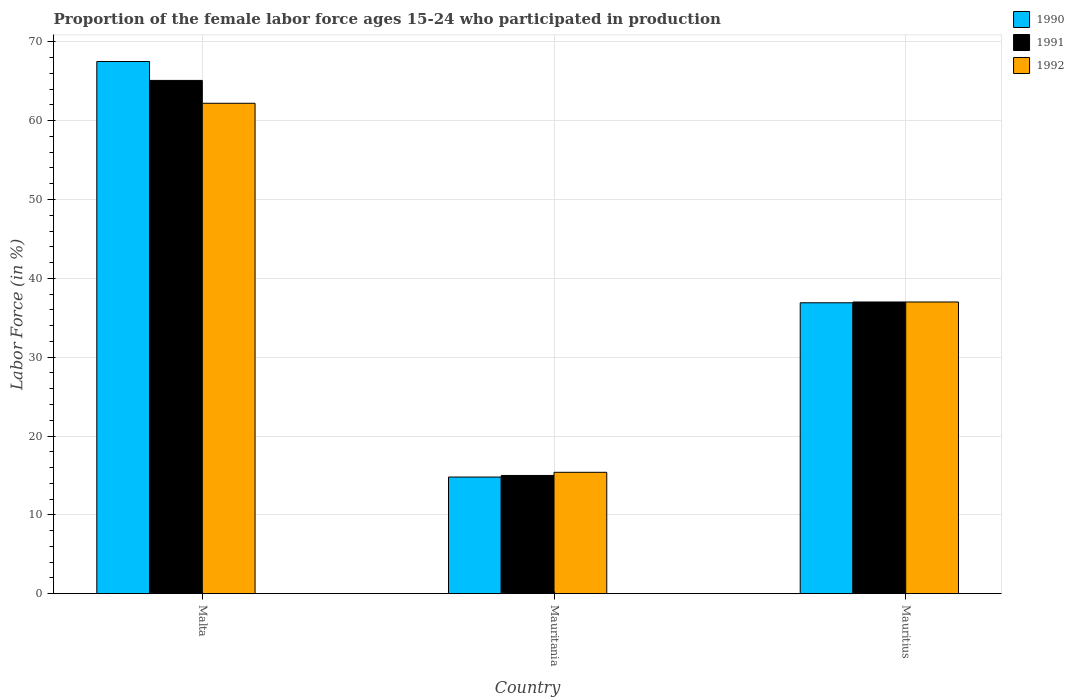How many groups of bars are there?
Offer a very short reply. 3. Are the number of bars on each tick of the X-axis equal?
Provide a short and direct response. Yes. How many bars are there on the 2nd tick from the left?
Ensure brevity in your answer.  3. How many bars are there on the 1st tick from the right?
Your answer should be very brief. 3. What is the label of the 1st group of bars from the left?
Give a very brief answer. Malta. In how many cases, is the number of bars for a given country not equal to the number of legend labels?
Offer a very short reply. 0. What is the proportion of the female labor force who participated in production in 1990 in Mauritania?
Provide a succinct answer. 14.8. Across all countries, what is the maximum proportion of the female labor force who participated in production in 1992?
Offer a very short reply. 62.2. Across all countries, what is the minimum proportion of the female labor force who participated in production in 1990?
Provide a short and direct response. 14.8. In which country was the proportion of the female labor force who participated in production in 1990 maximum?
Keep it short and to the point. Malta. In which country was the proportion of the female labor force who participated in production in 1992 minimum?
Offer a terse response. Mauritania. What is the total proportion of the female labor force who participated in production in 1992 in the graph?
Make the answer very short. 114.6. What is the difference between the proportion of the female labor force who participated in production in 1991 in Malta and the proportion of the female labor force who participated in production in 1990 in Mauritania?
Offer a terse response. 50.3. What is the average proportion of the female labor force who participated in production in 1990 per country?
Your answer should be compact. 39.73. What is the difference between the proportion of the female labor force who participated in production of/in 1990 and proportion of the female labor force who participated in production of/in 1991 in Malta?
Keep it short and to the point. 2.4. In how many countries, is the proportion of the female labor force who participated in production in 1992 greater than 32 %?
Offer a very short reply. 2. What is the ratio of the proportion of the female labor force who participated in production in 1992 in Malta to that in Mauritius?
Keep it short and to the point. 1.68. What is the difference between the highest and the second highest proportion of the female labor force who participated in production in 1992?
Your response must be concise. -25.2. What is the difference between the highest and the lowest proportion of the female labor force who participated in production in 1992?
Give a very brief answer. 46.8. Is the sum of the proportion of the female labor force who participated in production in 1990 in Malta and Mauritania greater than the maximum proportion of the female labor force who participated in production in 1992 across all countries?
Make the answer very short. Yes. What does the 1st bar from the left in Mauritania represents?
Your answer should be very brief. 1990. What does the 1st bar from the right in Mauritius represents?
Your answer should be very brief. 1992. Are all the bars in the graph horizontal?
Provide a succinct answer. No. How many countries are there in the graph?
Make the answer very short. 3. Are the values on the major ticks of Y-axis written in scientific E-notation?
Your answer should be compact. No. Does the graph contain any zero values?
Your answer should be very brief. No. Does the graph contain grids?
Provide a short and direct response. Yes. Where does the legend appear in the graph?
Provide a succinct answer. Top right. How many legend labels are there?
Keep it short and to the point. 3. What is the title of the graph?
Make the answer very short. Proportion of the female labor force ages 15-24 who participated in production. Does "2004" appear as one of the legend labels in the graph?
Offer a very short reply. No. What is the label or title of the Y-axis?
Your answer should be very brief. Labor Force (in %). What is the Labor Force (in %) in 1990 in Malta?
Offer a very short reply. 67.5. What is the Labor Force (in %) of 1991 in Malta?
Provide a succinct answer. 65.1. What is the Labor Force (in %) of 1992 in Malta?
Offer a terse response. 62.2. What is the Labor Force (in %) of 1990 in Mauritania?
Your answer should be compact. 14.8. What is the Labor Force (in %) in 1991 in Mauritania?
Provide a succinct answer. 15. What is the Labor Force (in %) of 1992 in Mauritania?
Your response must be concise. 15.4. What is the Labor Force (in %) in 1990 in Mauritius?
Your answer should be very brief. 36.9. Across all countries, what is the maximum Labor Force (in %) of 1990?
Your response must be concise. 67.5. Across all countries, what is the maximum Labor Force (in %) in 1991?
Your answer should be compact. 65.1. Across all countries, what is the maximum Labor Force (in %) of 1992?
Make the answer very short. 62.2. Across all countries, what is the minimum Labor Force (in %) in 1990?
Your answer should be very brief. 14.8. Across all countries, what is the minimum Labor Force (in %) of 1992?
Keep it short and to the point. 15.4. What is the total Labor Force (in %) in 1990 in the graph?
Your response must be concise. 119.2. What is the total Labor Force (in %) of 1991 in the graph?
Provide a succinct answer. 117.1. What is the total Labor Force (in %) in 1992 in the graph?
Provide a succinct answer. 114.6. What is the difference between the Labor Force (in %) in 1990 in Malta and that in Mauritania?
Make the answer very short. 52.7. What is the difference between the Labor Force (in %) in 1991 in Malta and that in Mauritania?
Offer a very short reply. 50.1. What is the difference between the Labor Force (in %) in 1992 in Malta and that in Mauritania?
Your response must be concise. 46.8. What is the difference between the Labor Force (in %) of 1990 in Malta and that in Mauritius?
Ensure brevity in your answer.  30.6. What is the difference between the Labor Force (in %) in 1991 in Malta and that in Mauritius?
Keep it short and to the point. 28.1. What is the difference between the Labor Force (in %) of 1992 in Malta and that in Mauritius?
Give a very brief answer. 25.2. What is the difference between the Labor Force (in %) of 1990 in Mauritania and that in Mauritius?
Your response must be concise. -22.1. What is the difference between the Labor Force (in %) of 1991 in Mauritania and that in Mauritius?
Ensure brevity in your answer.  -22. What is the difference between the Labor Force (in %) in 1992 in Mauritania and that in Mauritius?
Offer a very short reply. -21.6. What is the difference between the Labor Force (in %) in 1990 in Malta and the Labor Force (in %) in 1991 in Mauritania?
Give a very brief answer. 52.5. What is the difference between the Labor Force (in %) of 1990 in Malta and the Labor Force (in %) of 1992 in Mauritania?
Make the answer very short. 52.1. What is the difference between the Labor Force (in %) in 1991 in Malta and the Labor Force (in %) in 1992 in Mauritania?
Offer a terse response. 49.7. What is the difference between the Labor Force (in %) in 1990 in Malta and the Labor Force (in %) in 1991 in Mauritius?
Give a very brief answer. 30.5. What is the difference between the Labor Force (in %) in 1990 in Malta and the Labor Force (in %) in 1992 in Mauritius?
Your answer should be compact. 30.5. What is the difference between the Labor Force (in %) in 1991 in Malta and the Labor Force (in %) in 1992 in Mauritius?
Make the answer very short. 28.1. What is the difference between the Labor Force (in %) of 1990 in Mauritania and the Labor Force (in %) of 1991 in Mauritius?
Ensure brevity in your answer.  -22.2. What is the difference between the Labor Force (in %) in 1990 in Mauritania and the Labor Force (in %) in 1992 in Mauritius?
Your answer should be compact. -22.2. What is the average Labor Force (in %) of 1990 per country?
Keep it short and to the point. 39.73. What is the average Labor Force (in %) in 1991 per country?
Keep it short and to the point. 39.03. What is the average Labor Force (in %) in 1992 per country?
Provide a succinct answer. 38.2. What is the difference between the Labor Force (in %) of 1990 and Labor Force (in %) of 1991 in Malta?
Ensure brevity in your answer.  2.4. What is the difference between the Labor Force (in %) of 1991 and Labor Force (in %) of 1992 in Malta?
Keep it short and to the point. 2.9. What is the difference between the Labor Force (in %) in 1990 and Labor Force (in %) in 1992 in Mauritania?
Make the answer very short. -0.6. What is the difference between the Labor Force (in %) of 1991 and Labor Force (in %) of 1992 in Mauritania?
Your answer should be very brief. -0.4. What is the difference between the Labor Force (in %) of 1990 and Labor Force (in %) of 1992 in Mauritius?
Offer a terse response. -0.1. What is the difference between the Labor Force (in %) in 1991 and Labor Force (in %) in 1992 in Mauritius?
Make the answer very short. 0. What is the ratio of the Labor Force (in %) of 1990 in Malta to that in Mauritania?
Make the answer very short. 4.56. What is the ratio of the Labor Force (in %) in 1991 in Malta to that in Mauritania?
Your answer should be compact. 4.34. What is the ratio of the Labor Force (in %) in 1992 in Malta to that in Mauritania?
Ensure brevity in your answer.  4.04. What is the ratio of the Labor Force (in %) of 1990 in Malta to that in Mauritius?
Give a very brief answer. 1.83. What is the ratio of the Labor Force (in %) of 1991 in Malta to that in Mauritius?
Your answer should be compact. 1.76. What is the ratio of the Labor Force (in %) in 1992 in Malta to that in Mauritius?
Your response must be concise. 1.68. What is the ratio of the Labor Force (in %) of 1990 in Mauritania to that in Mauritius?
Your answer should be compact. 0.4. What is the ratio of the Labor Force (in %) of 1991 in Mauritania to that in Mauritius?
Make the answer very short. 0.41. What is the ratio of the Labor Force (in %) in 1992 in Mauritania to that in Mauritius?
Your response must be concise. 0.42. What is the difference between the highest and the second highest Labor Force (in %) of 1990?
Keep it short and to the point. 30.6. What is the difference between the highest and the second highest Labor Force (in %) of 1991?
Your response must be concise. 28.1. What is the difference between the highest and the second highest Labor Force (in %) in 1992?
Keep it short and to the point. 25.2. What is the difference between the highest and the lowest Labor Force (in %) of 1990?
Provide a short and direct response. 52.7. What is the difference between the highest and the lowest Labor Force (in %) of 1991?
Your response must be concise. 50.1. What is the difference between the highest and the lowest Labor Force (in %) of 1992?
Keep it short and to the point. 46.8. 